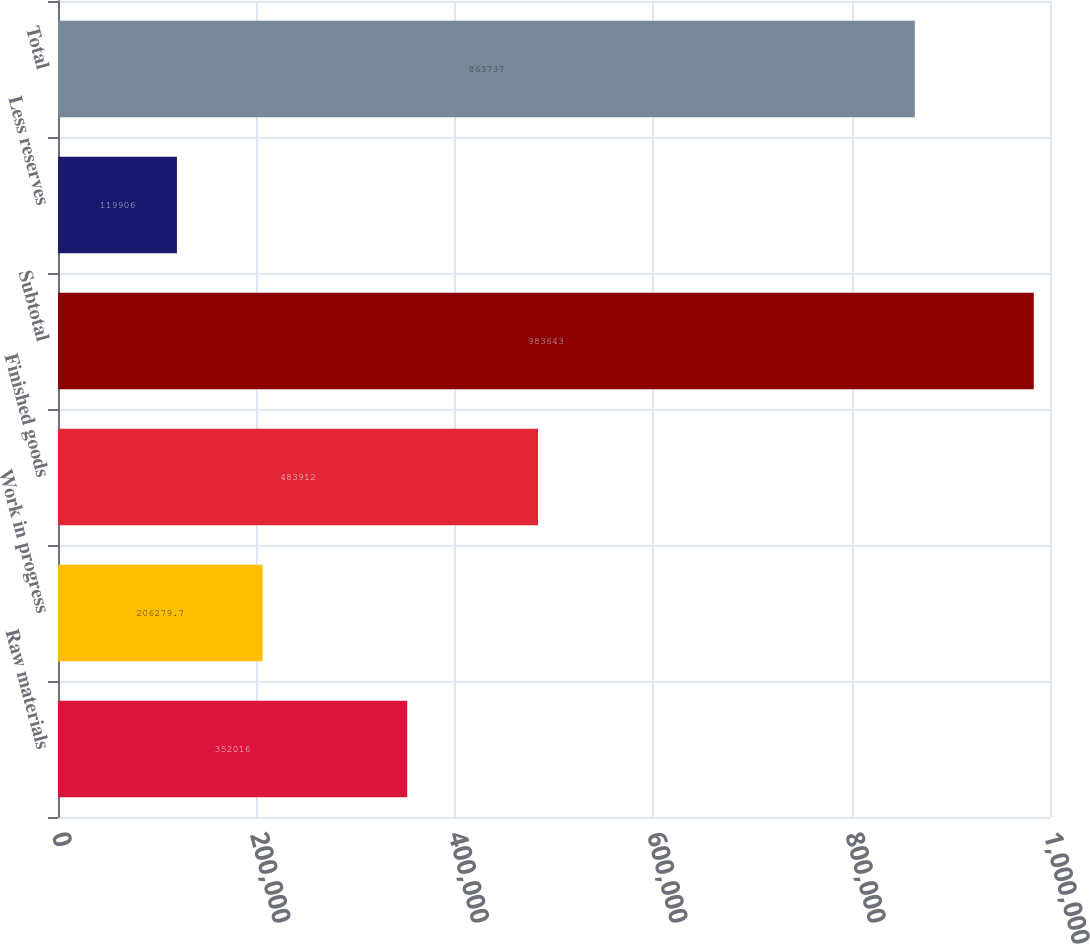Convert chart. <chart><loc_0><loc_0><loc_500><loc_500><bar_chart><fcel>Raw materials<fcel>Work in progress<fcel>Finished goods<fcel>Subtotal<fcel>Less reserves<fcel>Total<nl><fcel>352016<fcel>206280<fcel>483912<fcel>983643<fcel>119906<fcel>863737<nl></chart> 